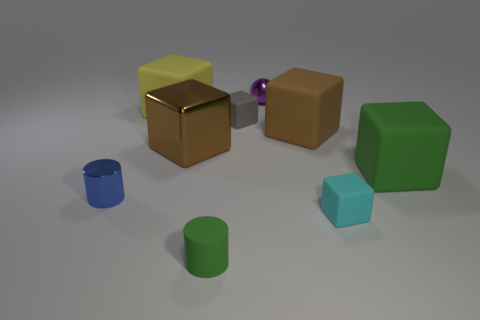Is there anything else that has the same shape as the yellow thing?
Make the answer very short. Yes. There is a green object that is right of the tiny matte cylinder; what is its shape?
Ensure brevity in your answer.  Cube. What shape is the small matte thing behind the tiny shiny thing in front of the green thing that is right of the small matte cylinder?
Provide a succinct answer. Cube. What number of objects are either small cyan metallic cubes or yellow things?
Provide a short and direct response. 1. Do the small shiny object that is behind the gray matte block and the tiny thing left of the brown shiny object have the same shape?
Your answer should be very brief. No. What number of rubber blocks are to the left of the small cyan cube and in front of the tiny gray block?
Offer a very short reply. 1. What number of other things are there of the same size as the yellow cube?
Ensure brevity in your answer.  3. What material is the object that is both in front of the big metal thing and to the left of the brown metallic object?
Your answer should be very brief. Metal. There is a matte cylinder; does it have the same color as the tiny block to the left of the small cyan rubber thing?
Ensure brevity in your answer.  No. There is a brown matte object that is the same shape as the cyan matte object; what size is it?
Offer a terse response. Large. 